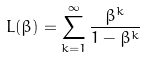<formula> <loc_0><loc_0><loc_500><loc_500>L ( \beta ) = \sum _ { k = 1 } ^ { \infty } \frac { \beta ^ { k } } { 1 - \beta ^ { k } }</formula> 